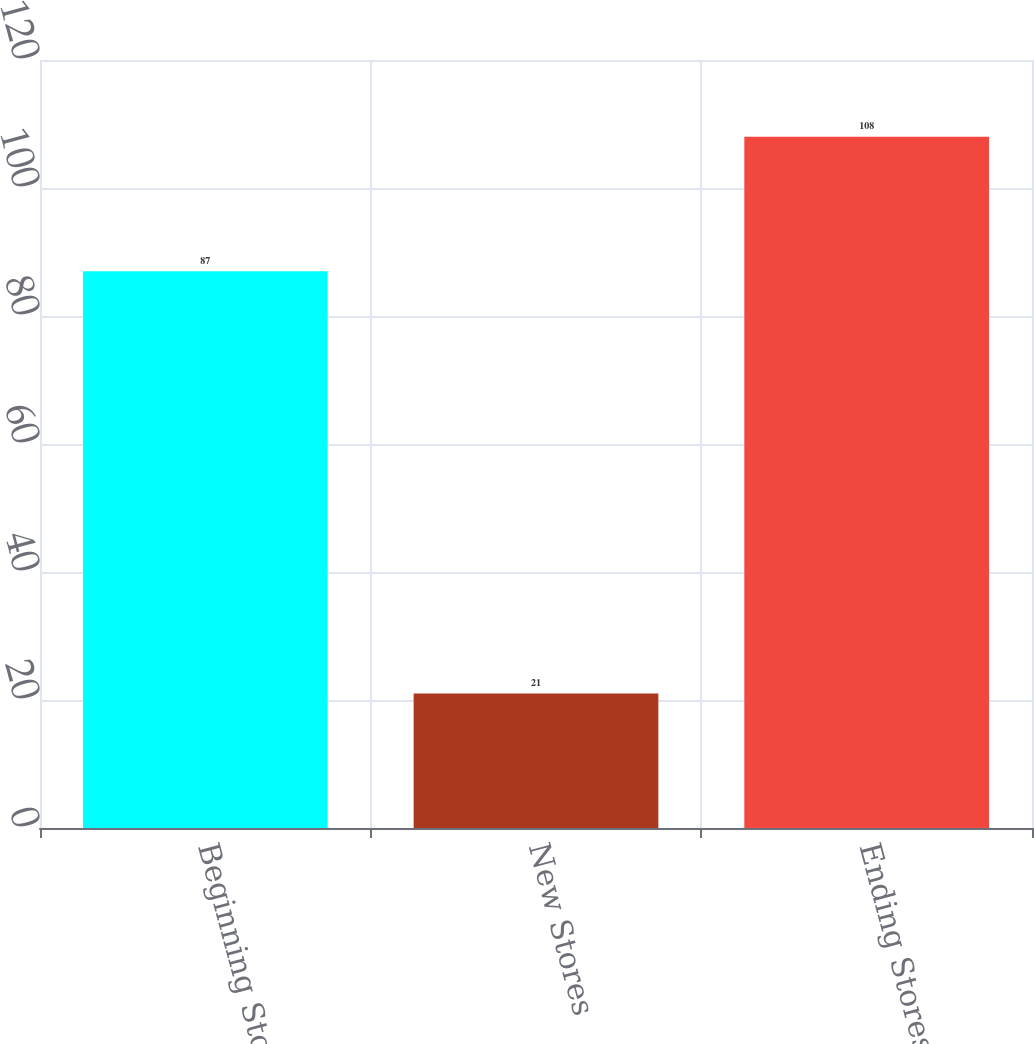<chart> <loc_0><loc_0><loc_500><loc_500><bar_chart><fcel>Beginning Stores<fcel>New Stores<fcel>Ending Stores<nl><fcel>87<fcel>21<fcel>108<nl></chart> 